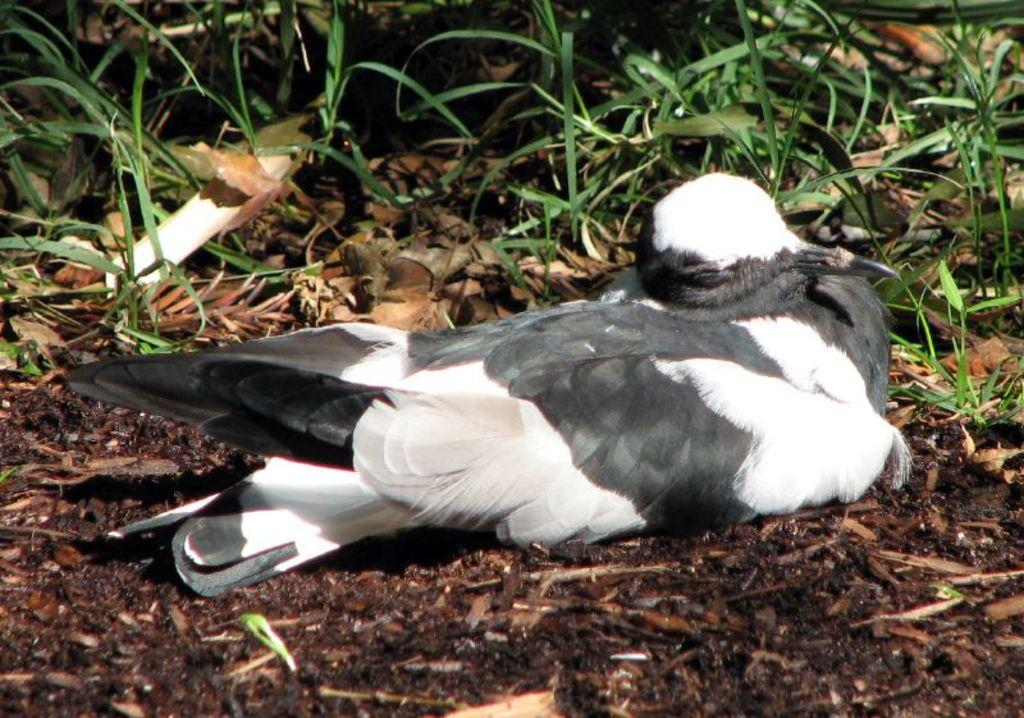What type of animal can be seen in the image? There is a bird in the image. What is at the bottom of the image? There is soil at the bottom of the image. What type of plant material is visible in the image? There are leaves visible in the image. What type of pollution can be seen in the image? There is no pollution visible in the image. What type of basket is being used to hold the leaves in the image? There is no basket present in the image. 